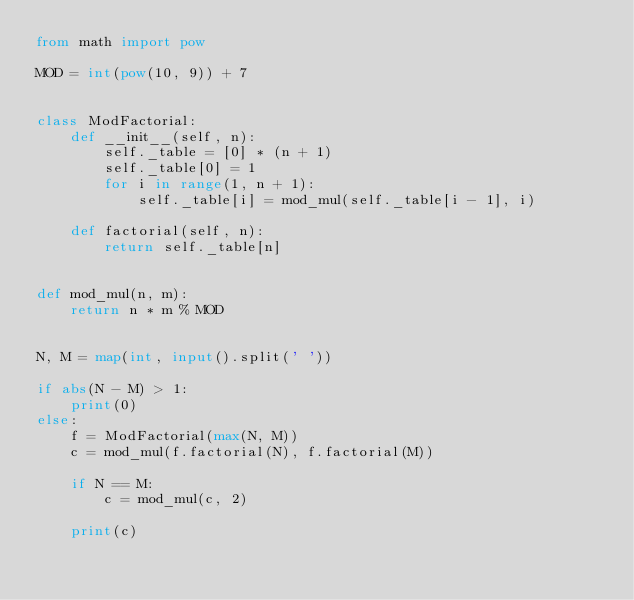Convert code to text. <code><loc_0><loc_0><loc_500><loc_500><_Python_>from math import pow

MOD = int(pow(10, 9)) + 7


class ModFactorial:
    def __init__(self, n):
        self._table = [0] * (n + 1)
        self._table[0] = 1
        for i in range(1, n + 1):
            self._table[i] = mod_mul(self._table[i - 1], i)

    def factorial(self, n):
        return self._table[n]


def mod_mul(n, m):
    return n * m % MOD


N, M = map(int, input().split(' '))

if abs(N - M) > 1:
    print(0)
else:
    f = ModFactorial(max(N, M))
    c = mod_mul(f.factorial(N), f.factorial(M))

    if N == M:
        c = mod_mul(c, 2)

    print(c)
</code> 